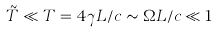<formula> <loc_0><loc_0><loc_500><loc_500>\tilde { T } \ll T = 4 \gamma L / c \sim \Omega L / c \ll 1</formula> 